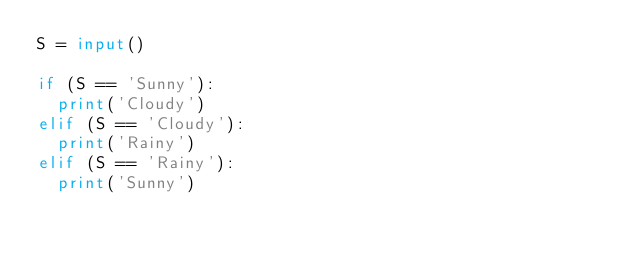<code> <loc_0><loc_0><loc_500><loc_500><_Python_>S = input()

if (S == 'Sunny'):
  print('Cloudy')
elif (S == 'Cloudy'):
  print('Rainy')
elif (S == 'Rainy'):
  print('Sunny')
</code> 